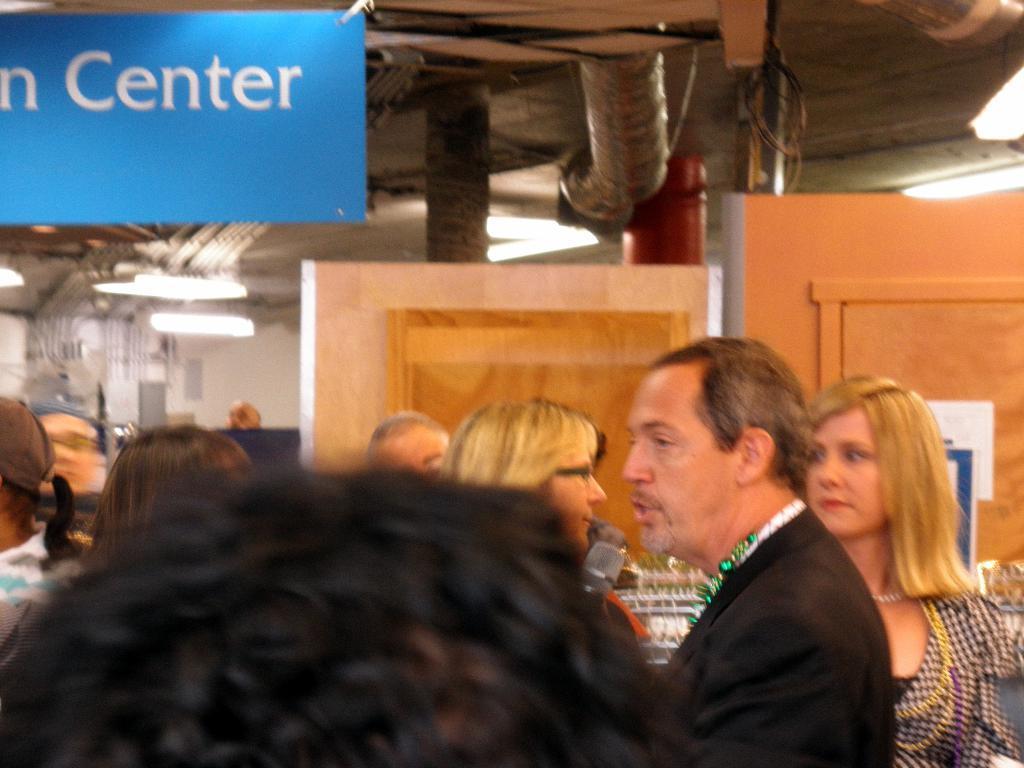Could you give a brief overview of what you see in this image? In this image we can see a group of people. In that we can see a man holding a mic. On the backside we can see some wooden doors, a board, wall and some ceiling lights to a roof. 